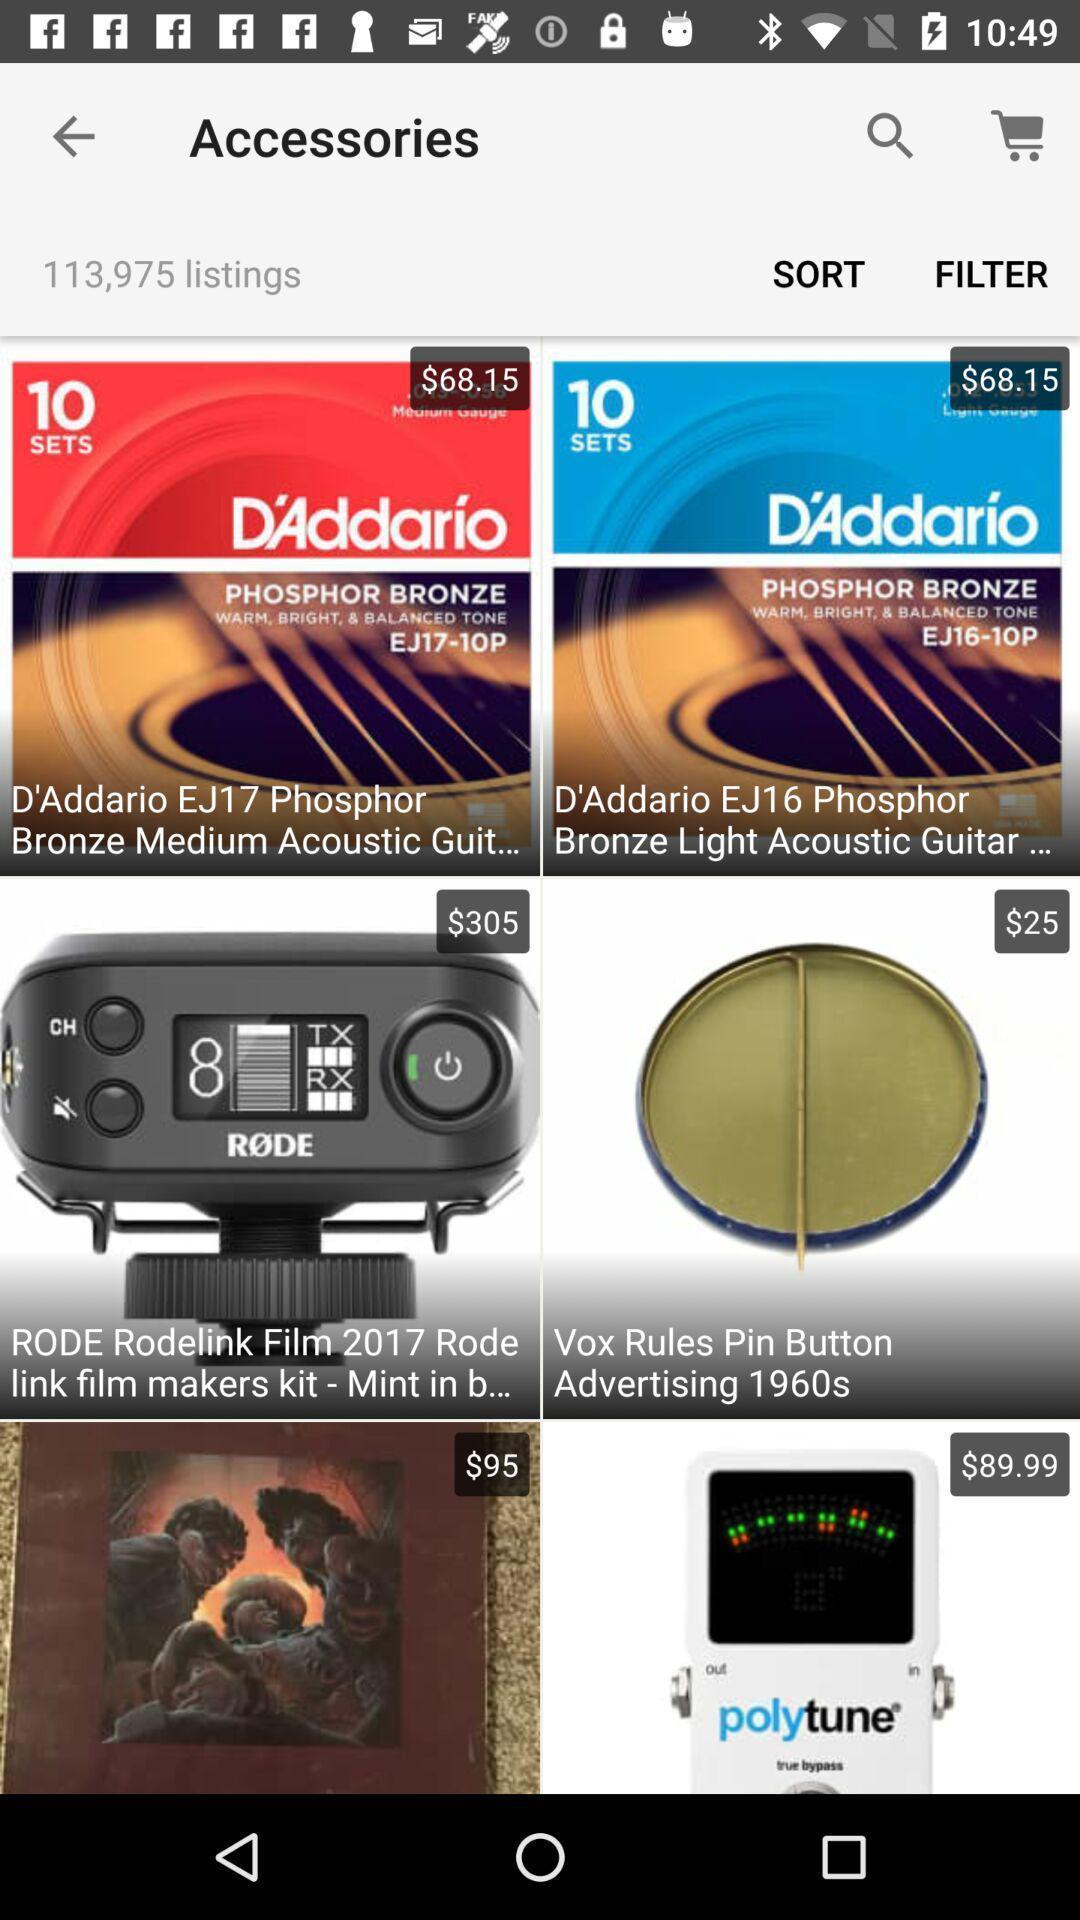Describe this image in words. Various accessories displayed of a online shopping app. 